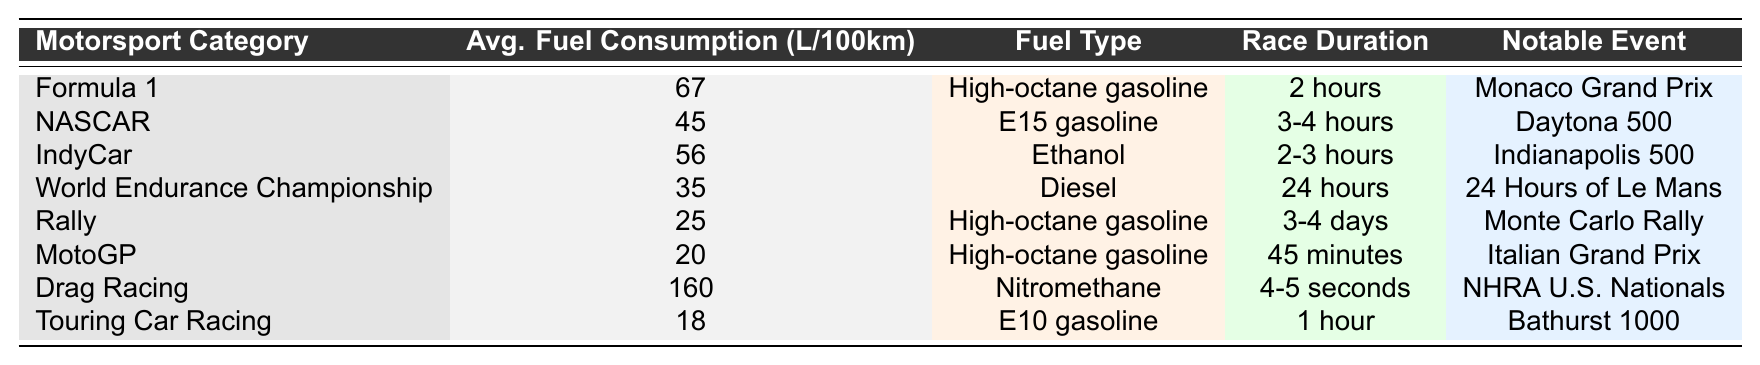What is the average fuel consumption for Formula 1? The table shows that Formula 1 has an average fuel consumption of 67 L/100km as stated in the corresponding row.
Answer: 67 L/100km Which motorsport category uses Ethanol as fuel? According to the table, the IndyCar category is the one that uses Ethanol as fuel, as indicated in its respective row.
Answer: IndyCar What is the total fuel consumption of the Rally and MotoGP categories combined? For Rally, the average consumption is 25 L/100km and for MotoGP, it's 20 L/100km. Adding these values together: 25 + 20 = 45 L/100km.
Answer: 45 L/100km Is the average fuel consumption for Touring Car Racing less than 30 L/100km? The average fuel consumption for Touring Car Racing is 18 L/100km, which is indeed less than 30 L/100km. Thus, the statement is true.
Answer: Yes Which category has the highest average fuel consumption, and what is it? By examining the table, Drag Racing has the highest average fuel consumption at 160 L/100km listed in its row.
Answer: 160 L/100km How many motorsport categories have an average fuel consumption below 30 L/100km? From the table, there are three categories: World Endurance Championship (35), Rally (25), MotoGP (20), and Touring Car Racing (18). Only Rally, MotoGP, and Touring Car Racing are below 30, giving a total of 4 categories.
Answer: 4 categories What is the fuel type for NASCAR, and how does it differ from that in Formula 1? NASCAR uses E15 gasoline while Formula 1 uses high-octane gasoline. The difference lies in the specific formulations, with one being blended with ethanol for NASCAR and high-octane for performance in Formula 1.
Answer: E15 gasoline, differs from high-octane gasoline Which motorsport category has the longest race duration? The World Endurance Championship has the longest race duration of 24 hours, as stated in the corresponding row of the table.
Answer: 24 hours If a vehicle in Drag Racing consumes fuel for 5 seconds instead of the average of 4-5 seconds, how much would the fuel consumption change in comparison to the average? Drag Racing averages 160 L/100km. Since the duration doesn't change the L/100km ratio, the fuel consumption remains the same, barring duration adjustment. Therefore, the change in fuel consumption in terms of liters in a 5-second duration doesn't alter the L/100km efficiency but may reduce total liters consumed depending on distance covered.
Answer: No change in L/100km but total liters might vary What notable event is associated with the IndyCar category? The Indianapolis 500 is the notable event linked with the IndyCar category, as indicated in its respective row of the table.
Answer: Indianapolis 500 